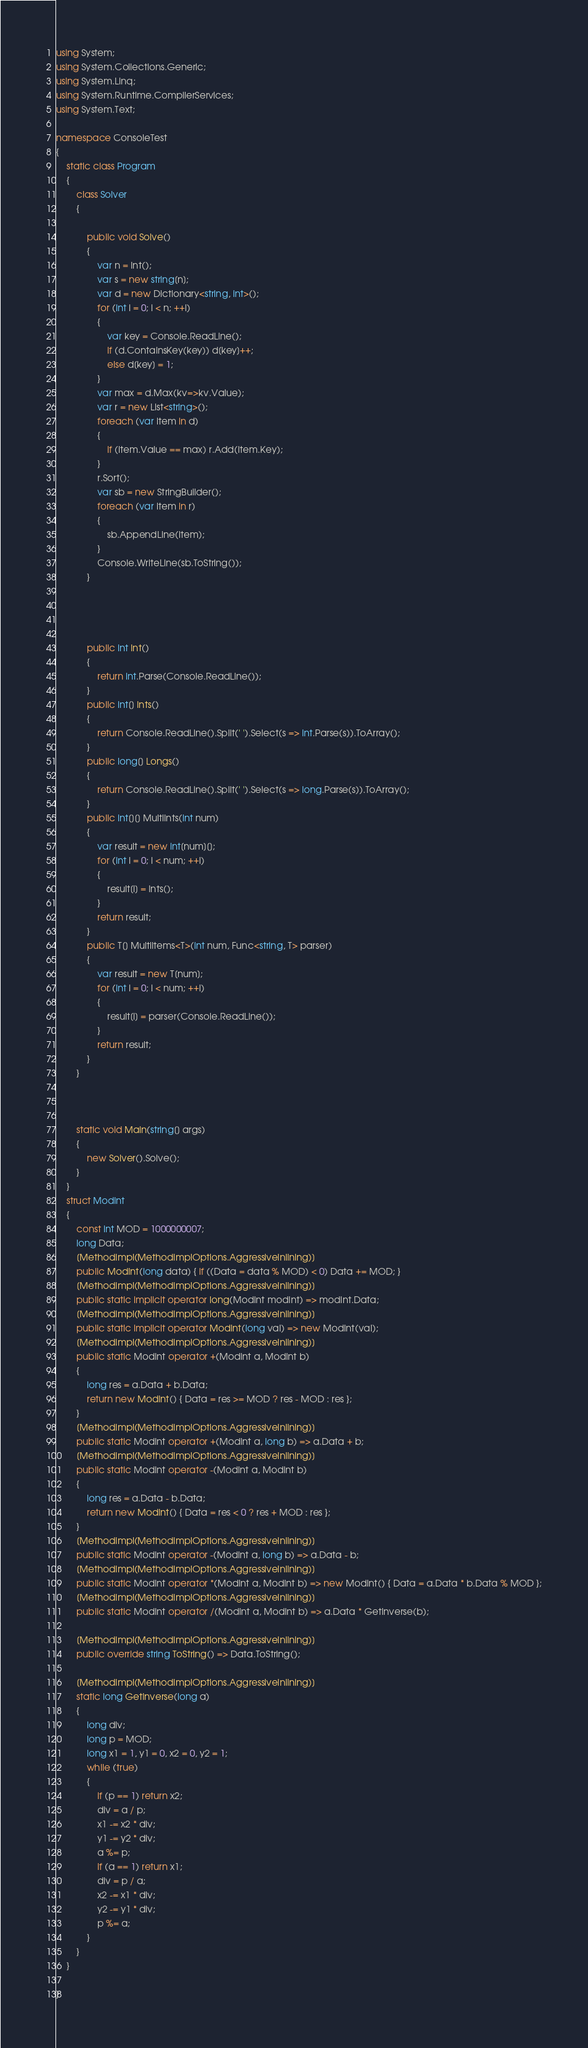<code> <loc_0><loc_0><loc_500><loc_500><_C#_>using System;
using System.Collections.Generic;
using System.Linq;
using System.Runtime.CompilerServices;
using System.Text;

namespace ConsoleTest
{
    static class Program
    {
        class Solver
        {

            public void Solve()
            {
                var n = Int();
                var s = new string[n];
                var d = new Dictionary<string, int>();
                for (int i = 0; i < n; ++i)
                {
                    var key = Console.ReadLine();
                    if (d.ContainsKey(key)) d[key]++;
                    else d[key] = 1;
                }
                var max = d.Max(kv=>kv.Value);
                var r = new List<string>();
                foreach (var item in d)
                {
                    if (item.Value == max) r.Add(item.Key);
                }
                r.Sort();
                var sb = new StringBuilder();
                foreach (var item in r)
                {
                    sb.AppendLine(item);
                }
                Console.WriteLine(sb.ToString());
            }
          



            public int Int()
            {
                return int.Parse(Console.ReadLine());
            }
            public int[] Ints()
            {
                return Console.ReadLine().Split(' ').Select(s => int.Parse(s)).ToArray();
            }
            public long[] Longs()
            {
                return Console.ReadLine().Split(' ').Select(s => long.Parse(s)).ToArray();
            }
            public int[][] MultiInts(int num)
            {
                var result = new int[num][];
                for (int i = 0; i < num; ++i)
                {
                    result[i] = Ints();
                }
                return result;
            }
            public T[] MultiItems<T>(int num, Func<string, T> parser)
            {
                var result = new T[num];
                for (int i = 0; i < num; ++i)
                {
                    result[i] = parser(Console.ReadLine());
                }
                return result;
            }
        }
        
  

        static void Main(string[] args)
        {
            new Solver().Solve();
        }
    }
    struct ModInt
    {
        const int MOD = 1000000007;
        long Data;
        [MethodImpl(MethodImplOptions.AggressiveInlining)]
        public ModInt(long data) { if ((Data = data % MOD) < 0) Data += MOD; }
        [MethodImpl(MethodImplOptions.AggressiveInlining)]
        public static implicit operator long(ModInt modInt) => modInt.Data;
        [MethodImpl(MethodImplOptions.AggressiveInlining)]
        public static implicit operator ModInt(long val) => new ModInt(val);
        [MethodImpl(MethodImplOptions.AggressiveInlining)]
        public static ModInt operator +(ModInt a, ModInt b)
        {
            long res = a.Data + b.Data;
            return new ModInt() { Data = res >= MOD ? res - MOD : res };
        }
        [MethodImpl(MethodImplOptions.AggressiveInlining)]
        public static ModInt operator +(ModInt a, long b) => a.Data + b;
        [MethodImpl(MethodImplOptions.AggressiveInlining)]
        public static ModInt operator -(ModInt a, ModInt b)
        {
            long res = a.Data - b.Data;
            return new ModInt() { Data = res < 0 ? res + MOD : res };
        }
        [MethodImpl(MethodImplOptions.AggressiveInlining)]
        public static ModInt operator -(ModInt a, long b) => a.Data - b;
        [MethodImpl(MethodImplOptions.AggressiveInlining)]
        public static ModInt operator *(ModInt a, ModInt b) => new ModInt() { Data = a.Data * b.Data % MOD };
        [MethodImpl(MethodImplOptions.AggressiveInlining)]
        public static ModInt operator /(ModInt a, ModInt b) => a.Data * GetInverse(b);

        [MethodImpl(MethodImplOptions.AggressiveInlining)]
        public override string ToString() => Data.ToString();

        [MethodImpl(MethodImplOptions.AggressiveInlining)]
        static long GetInverse(long a)
        {
            long div;
            long p = MOD;
            long x1 = 1, y1 = 0, x2 = 0, y2 = 1;
            while (true)
            {
                if (p == 1) return x2;
                div = a / p;
                x1 -= x2 * div;
                y1 -= y2 * div;
                a %= p;
                if (a == 1) return x1;
                div = p / a;
                x2 -= x1 * div;
                y2 -= y1 * div;
                p %= a;
            }
        }
    }

}
</code> 